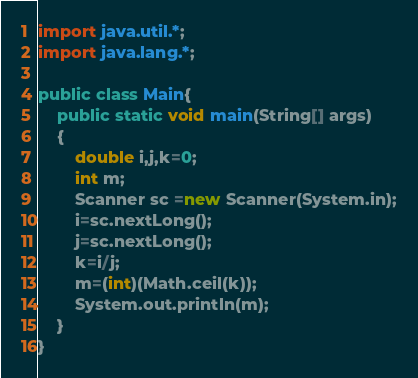<code> <loc_0><loc_0><loc_500><loc_500><_Java_>

import java.util.*;
import java.lang.*;

public class Main{
    public static void main(String[] args)
    {
        double i,j,k=0;
        int m;
        Scanner sc =new Scanner(System.in);
        i=sc.nextLong();
        j=sc.nextLong();
        k=i/j;
        m=(int)(Math.ceil(k));
        System.out.println(m);
    }
}</code> 